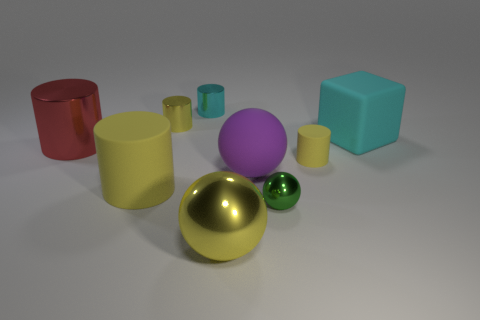Which object in the image seems out of place compared to the others? The red cylindrical object on the left stands out because it is the only object with a bright, saturated color in contrast to the other objects' more subdued hues. Its color draws the eye and makes it a focal point among the items present. Why do you think that object was made to stand out like that? In visual compositions, contrasting colors can be used to attract attention to specific items or to create visually interesting scenes. The red object's placement and color may be an intentional choice to add vibrancy and contrast to the scene, or to highlight it as unique amongst the other objects. 